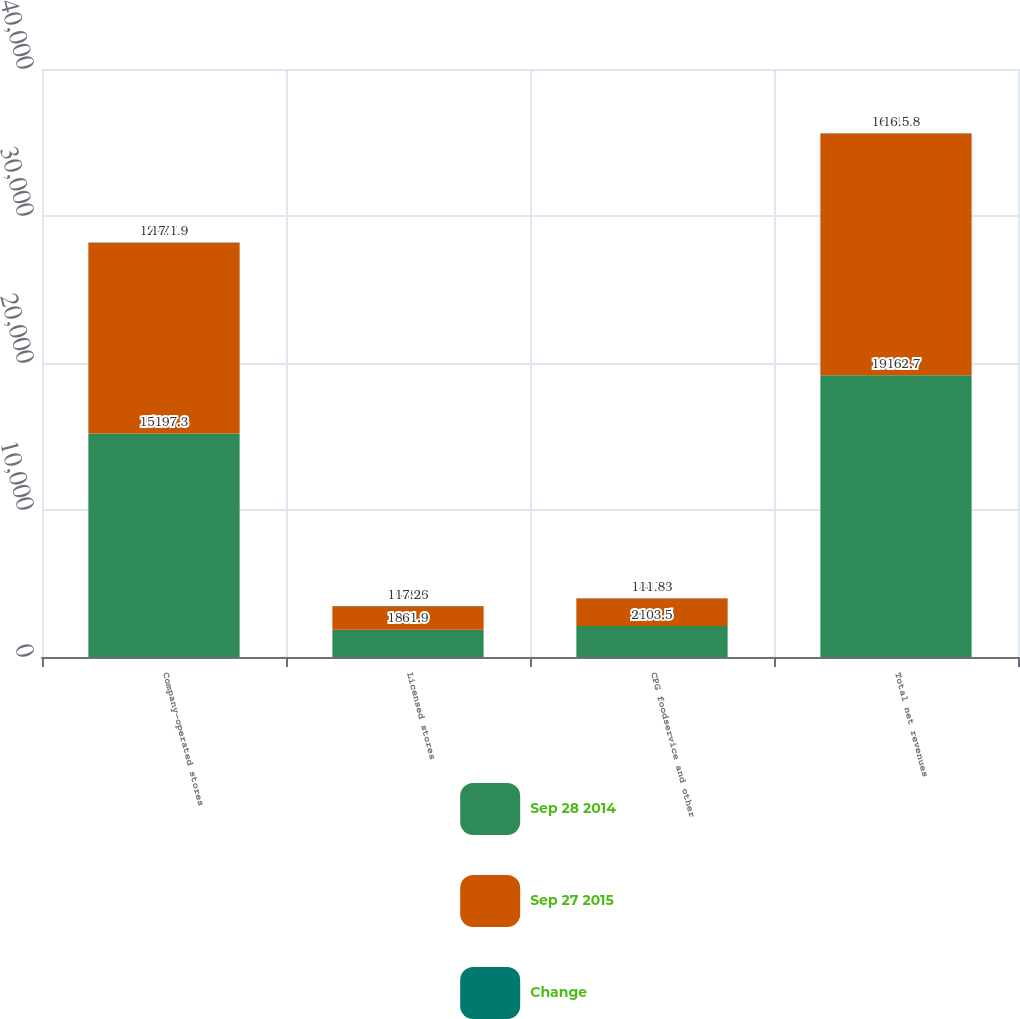<chart> <loc_0><loc_0><loc_500><loc_500><stacked_bar_chart><ecel><fcel>Company-operated stores<fcel>Licensed stores<fcel>CPG foodservice and other<fcel>Total net revenues<nl><fcel>Sep 28 2014<fcel>15197.3<fcel>1861.9<fcel>2103.5<fcel>19162.7<nl><fcel>Sep 27 2015<fcel>12977.9<fcel>1588.6<fcel>1881.3<fcel>16447.8<nl><fcel>Change<fcel>17.1<fcel>17.2<fcel>11.8<fcel>16.5<nl></chart> 